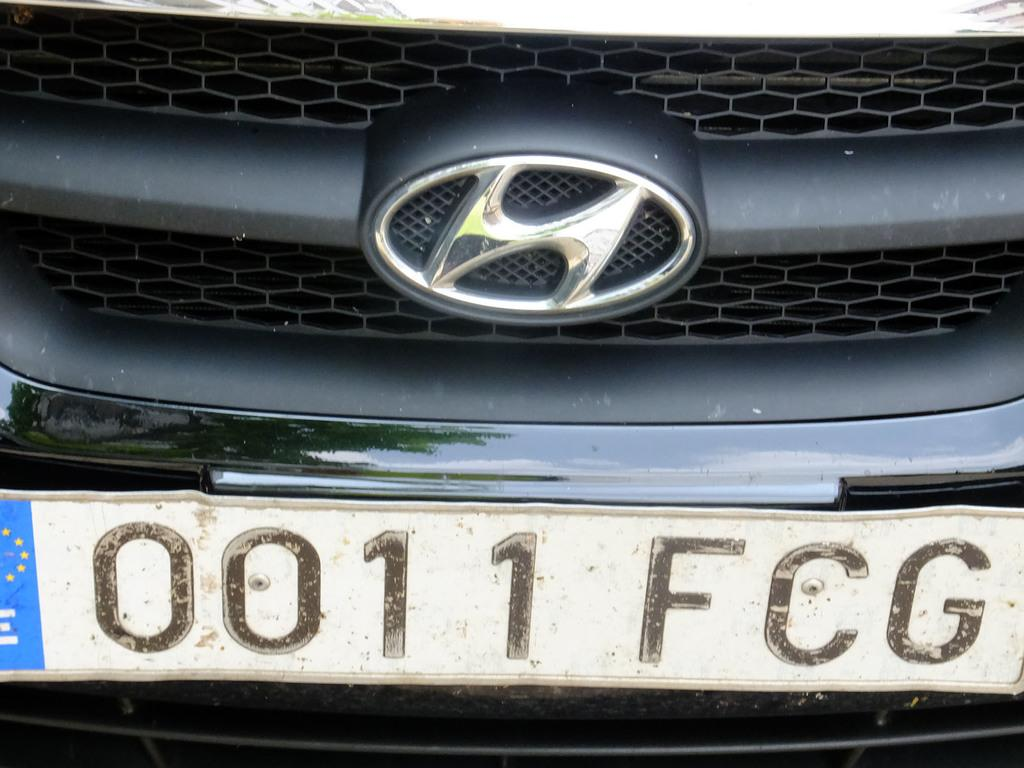Provide a one-sentence caption for the provided image. A black car has the numbers 0011 below the grill. 